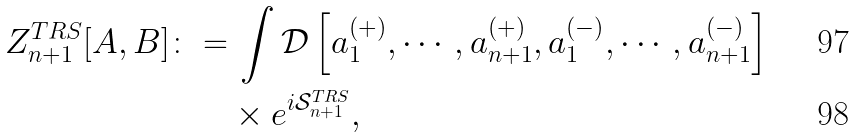<formula> <loc_0><loc_0><loc_500><loc_500>Z ^ { T R S } _ { n + 1 } [ A , B ] \colon = & \, \int \mathcal { D } \left [ a ^ { ( + ) } _ { 1 } , \cdots , a ^ { ( + ) } _ { n + 1 } , a ^ { ( - ) } _ { 1 } , \cdots , a ^ { ( - ) } _ { n + 1 } \right ] \\ & \times e ^ { i \mathcal { S } ^ { T R S } _ { n + 1 } } ,</formula> 